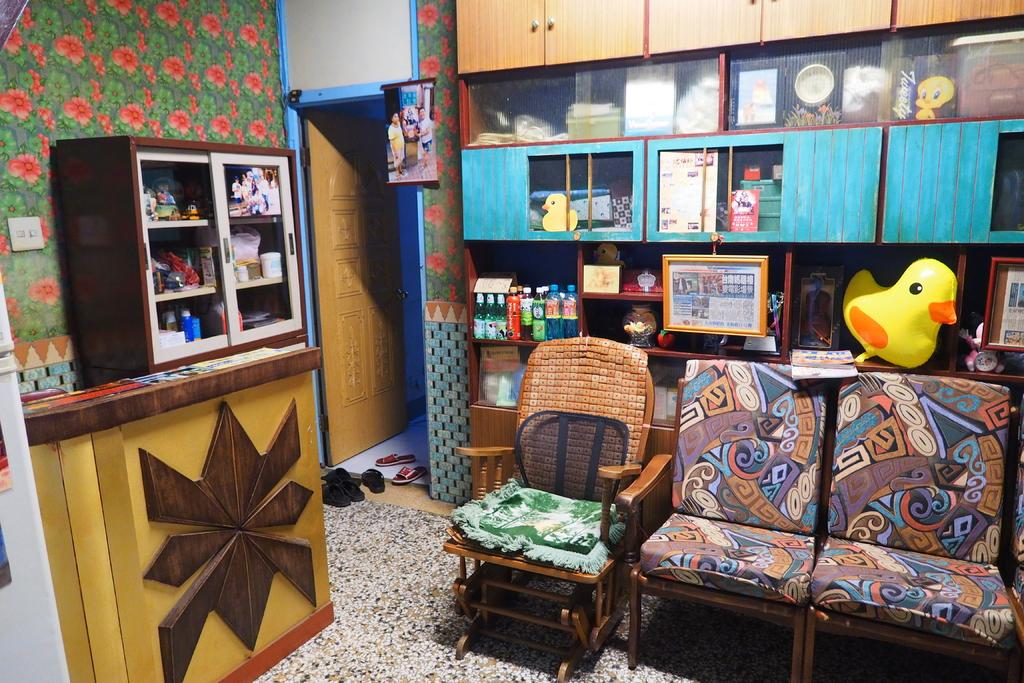What type of furniture is present in the room? There are chairs in the room. What type of footwear is present in the room? There are slippers in the room. What type of containers are present in the room? There are bottles in the room. What type of protective gear is present in the room? There are shields in the room. What type of play items are present in the room? There are toys in the room. How are these items arranged in the room? The items mentioned are in racks. What is the direction of the desire in the room? There is no mention of desire in the image, so this question cannot be answered. What is the measure of the north in the room? There is no mention of north or any measurement in the image, so this question cannot be answered. 